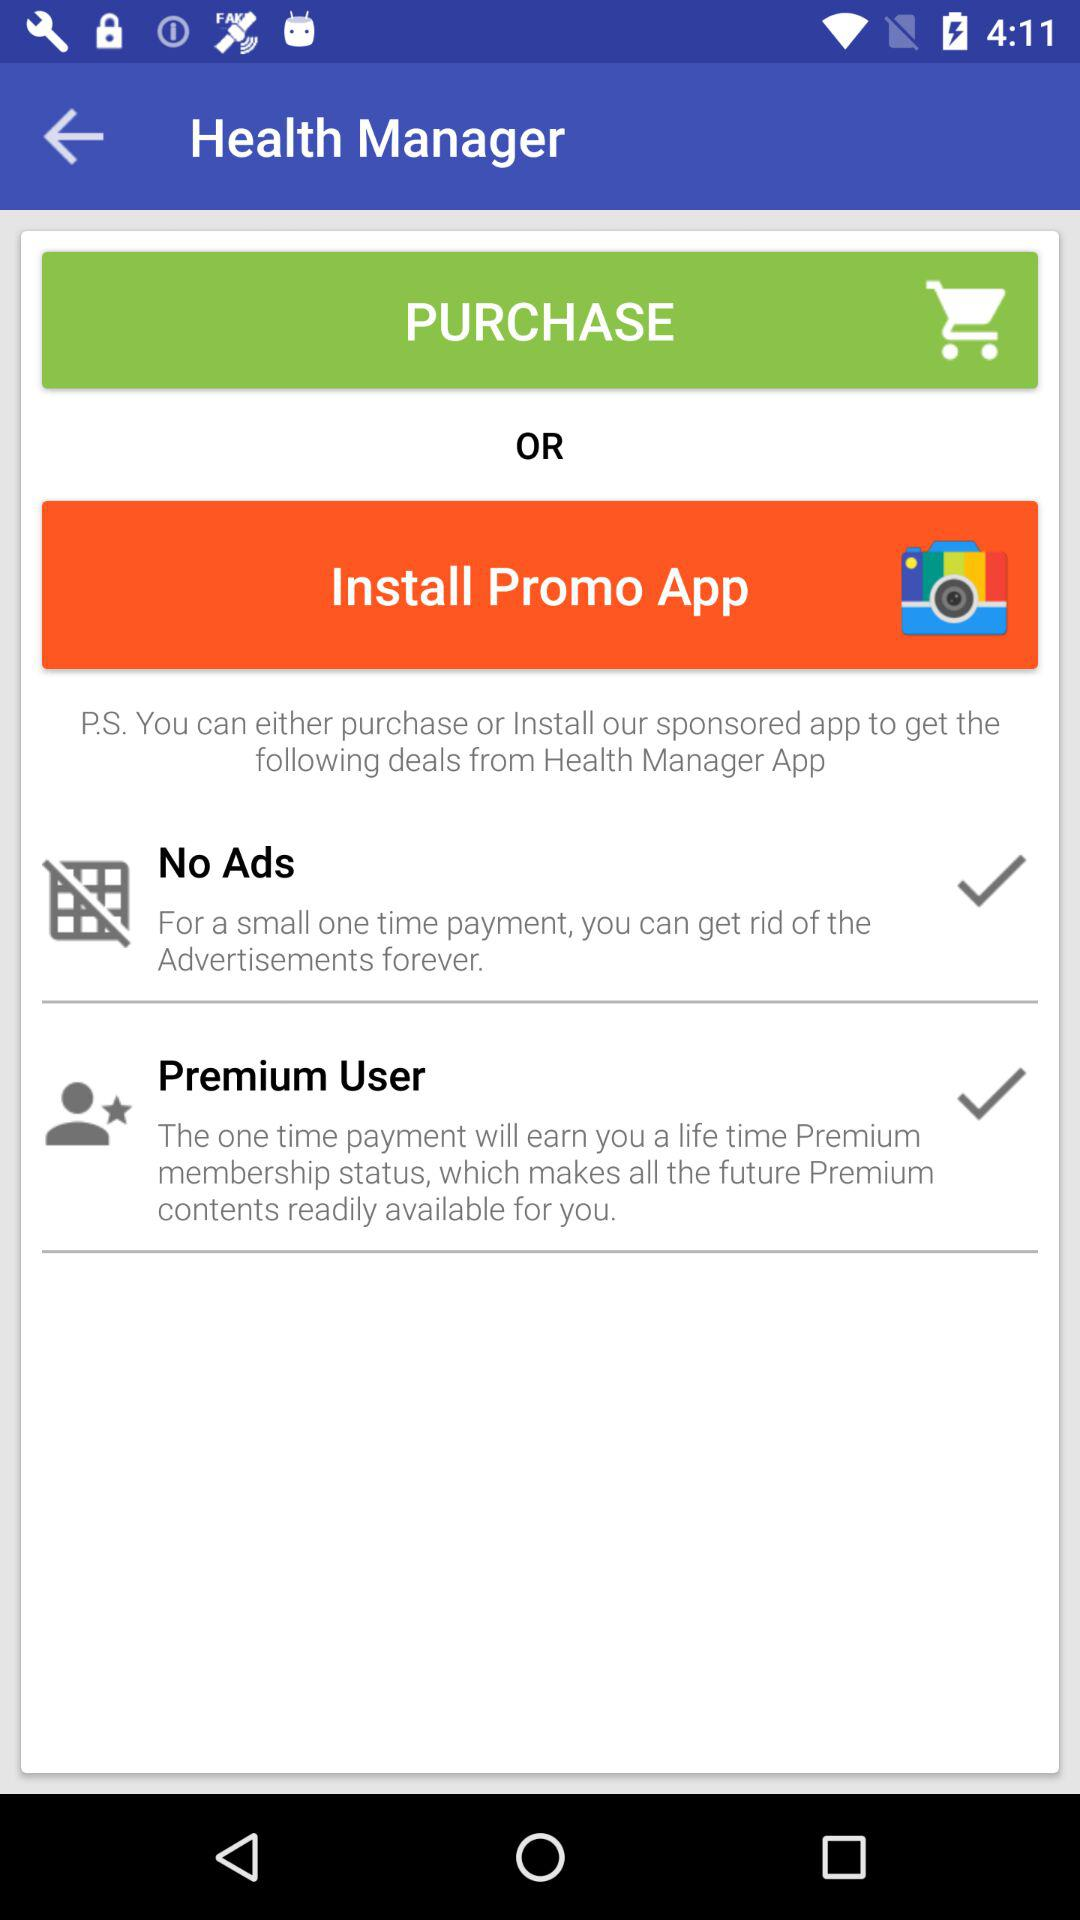How many deals are there in total?
Answer the question using a single word or phrase. 2 